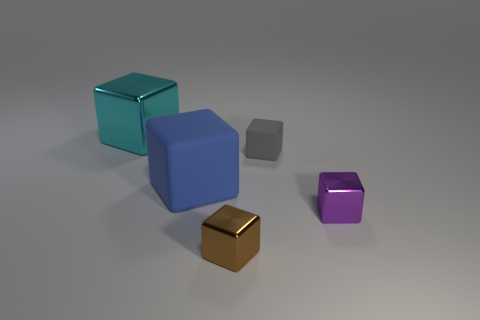Is the blue thing made of the same material as the large object behind the big blue thing?
Provide a short and direct response. No. How many blocks are behind the brown metallic thing and in front of the cyan object?
Give a very brief answer. 3. What shape is the cyan metal object that is the same size as the blue matte cube?
Make the answer very short. Cube. Are there any tiny gray objects behind the object behind the matte cube that is behind the blue cube?
Your answer should be very brief. No. There is a small matte thing; does it have the same color as the shiny thing in front of the purple metallic object?
Ensure brevity in your answer.  No. What number of small metal things are the same color as the big rubber cube?
Give a very brief answer. 0. There is a metal object behind the large object in front of the large metal block; what size is it?
Provide a succinct answer. Large. How many things are either objects that are on the left side of the purple metallic block or big matte blocks?
Ensure brevity in your answer.  4. Are there any brown metal cubes of the same size as the brown thing?
Offer a very short reply. No. Are there any tiny gray things behind the large block that is behind the gray thing?
Make the answer very short. No. 